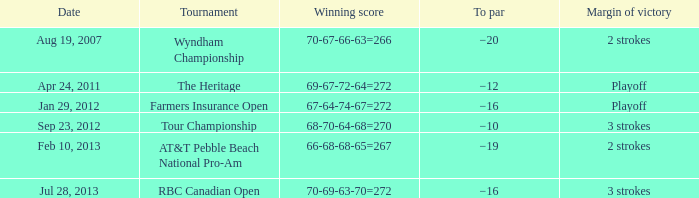What is the par for the game with a victorious score of 69-67-72-64=272? −12. 